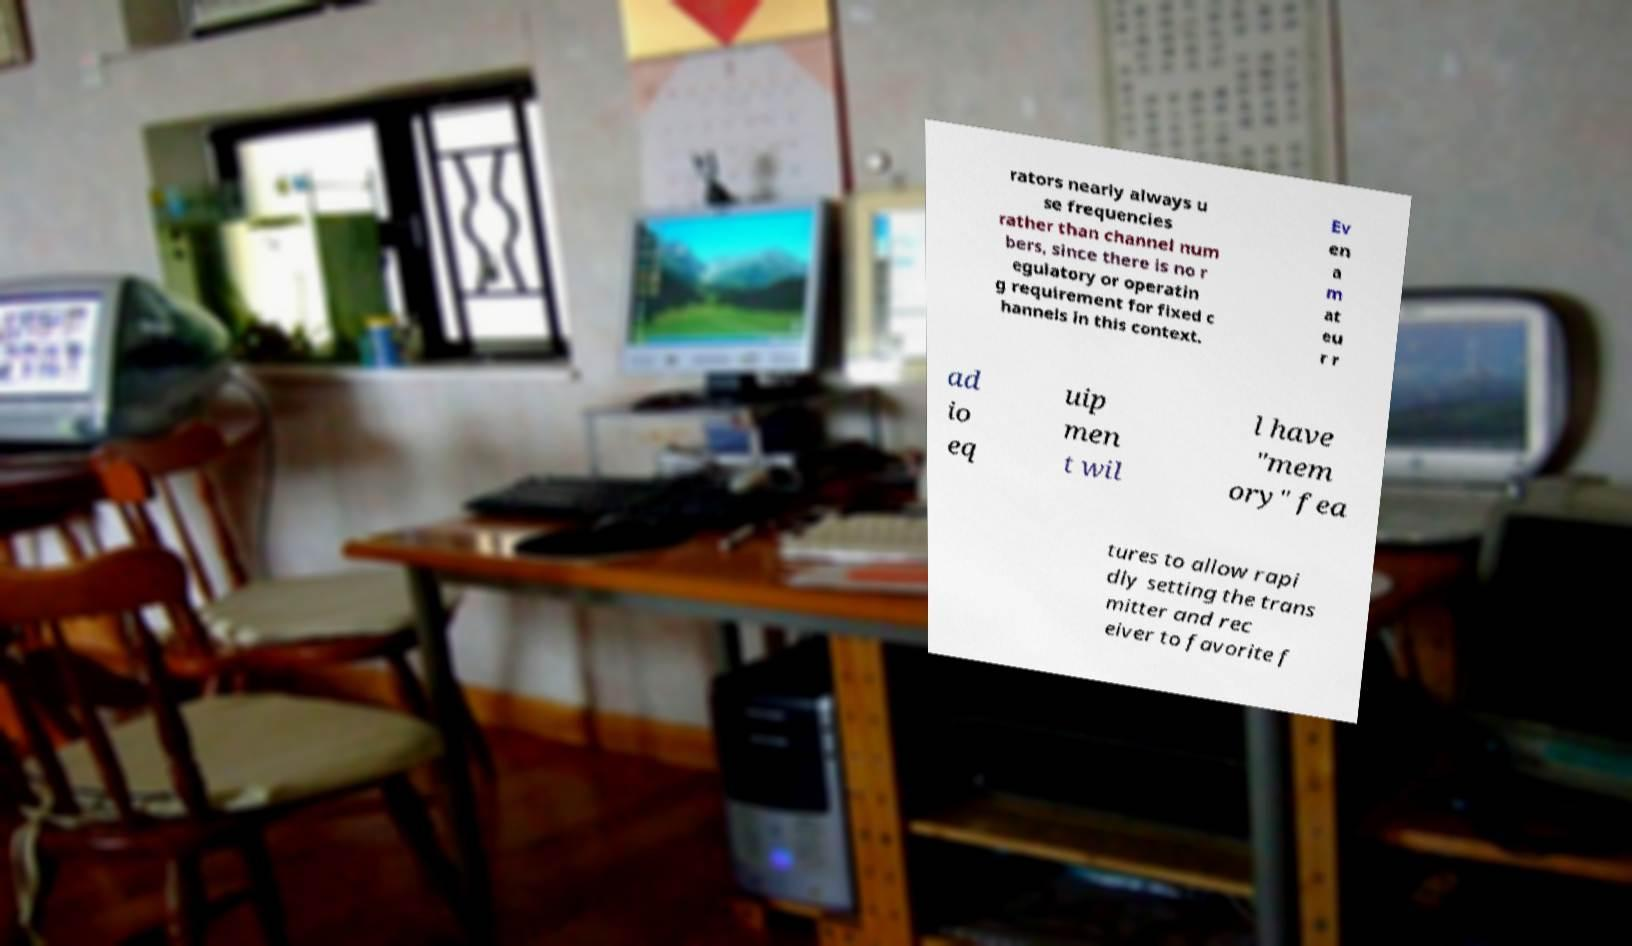Can you accurately transcribe the text from the provided image for me? rators nearly always u se frequencies rather than channel num bers, since there is no r egulatory or operatin g requirement for fixed c hannels in this context. Ev en a m at eu r r ad io eq uip men t wil l have "mem ory" fea tures to allow rapi dly setting the trans mitter and rec eiver to favorite f 